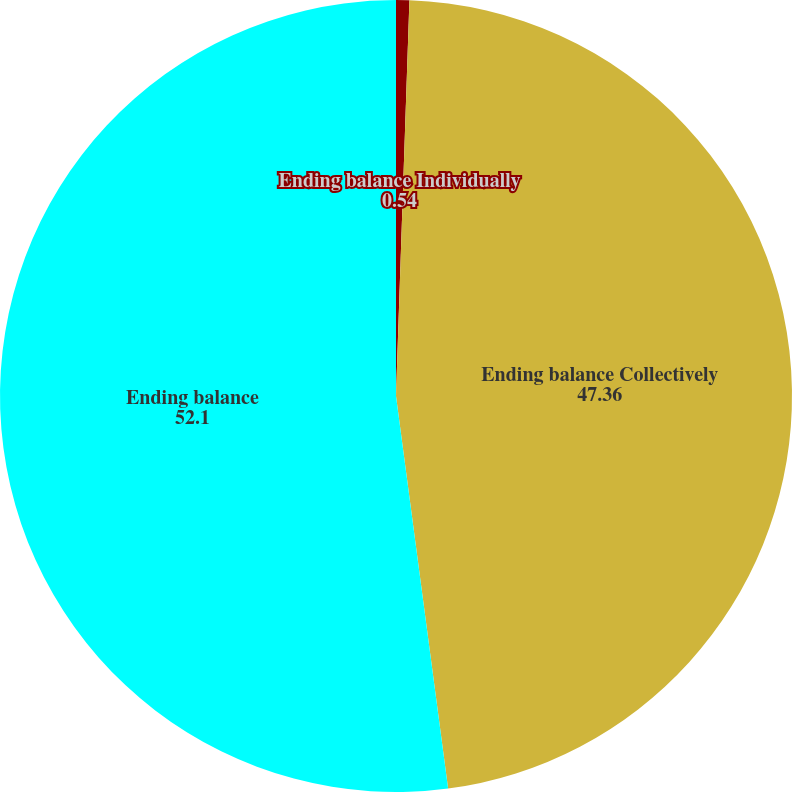Convert chart. <chart><loc_0><loc_0><loc_500><loc_500><pie_chart><fcel>Ending balance Individually<fcel>Ending balance Collectively<fcel>Ending balance<nl><fcel>0.54%<fcel>47.36%<fcel>52.1%<nl></chart> 